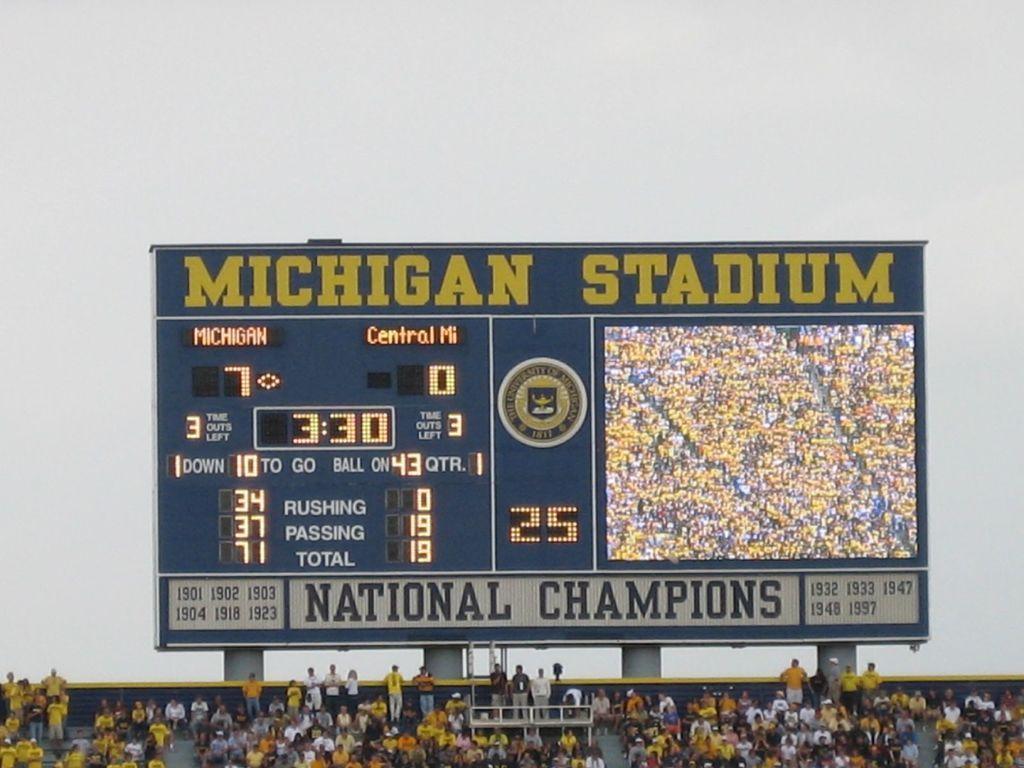Provide a one-sentence caption for the provided image. The scoreboard at Michigan Stadium is showing the score. 